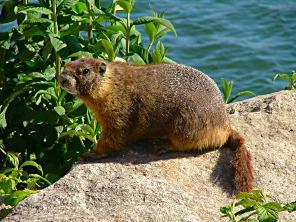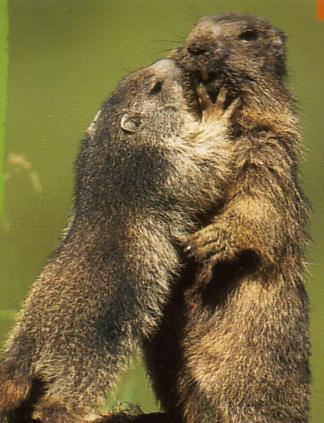The first image is the image on the left, the second image is the image on the right. Evaluate the accuracy of this statement regarding the images: "In one of the images, there are two animals facing left.". Is it true? Answer yes or no. No. The first image is the image on the left, the second image is the image on the right. Examine the images to the left and right. Is the description "An image shows two similarly-posed upright marmots, each facing leftward." accurate? Answer yes or no. No. 